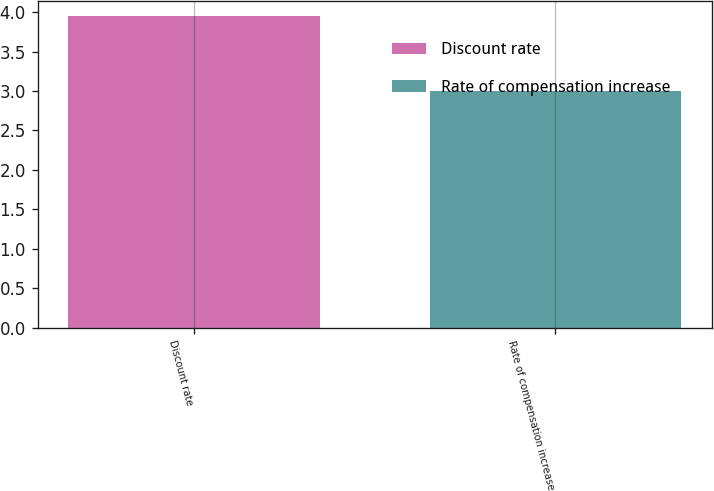Convert chart to OTSL. <chart><loc_0><loc_0><loc_500><loc_500><bar_chart><fcel>Discount rate<fcel>Rate of compensation increase<nl><fcel>3.95<fcel>3<nl></chart> 